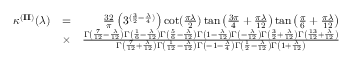Convert formula to latex. <formula><loc_0><loc_0><loc_500><loc_500>\begin{array} { r l r } { \kappa ^ { ( { I I } ) } ( \lambda ) } & { = } & { \frac { 3 2 } { \pi } \left ( 3 ^ { ( \frac { 3 } { 2 } - \frac { \lambda } { 4 } ) } \right ) \cot ( \frac { \pi \lambda } { 2 } ) \tan \left ( \frac { 3 \pi } { 4 } + \frac { \pi \lambda } { 1 2 } \right ) \tan \left ( \frac { \pi } { 6 } + \frac { \pi \lambda } { 1 2 } \right ) } \\ & { \times } & { \frac { \Gamma \left ( \frac { 7 } { 1 2 } - \frac { \lambda } { 1 2 } \right ) \Gamma \left ( \frac { 1 } { 6 } - \frac { \lambda } { 1 2 } \right ) \Gamma \left ( \frac { 5 } { 6 } - \frac { \lambda } { 1 2 } \right ) \Gamma \left ( 1 - \frac { \lambda } { 1 2 } \right ) \Gamma \left ( - \frac { \lambda } { 1 2 } \right ) \Gamma \left ( \frac { 3 } { 2 } + \frac { \lambda } { 1 2 } \right ) \Gamma \left ( \frac { 1 3 } { 1 2 } + \frac { \lambda } { 1 2 } \right ) } { \Gamma \left ( \frac { 7 } { 1 2 } + \frac { \lambda } { 1 2 } \right ) \Gamma \left ( \frac { 1 } { 1 2 } - \frac { \lambda } { 1 2 } \right ) \Gamma \left ( - 1 - \frac { \lambda } { 4 } \right ) \Gamma \left ( \frac { 1 } { 2 } - \frac { \lambda } { 1 2 } \right ) \Gamma \left ( 1 + \frac { \lambda } { 1 2 } \right ) } } \end{array}</formula> 